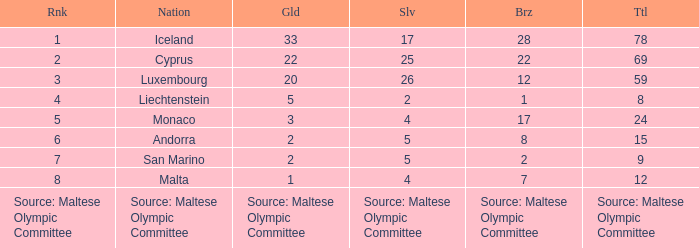What is the total medal count for the nation that has 5 gold? 8.0. 